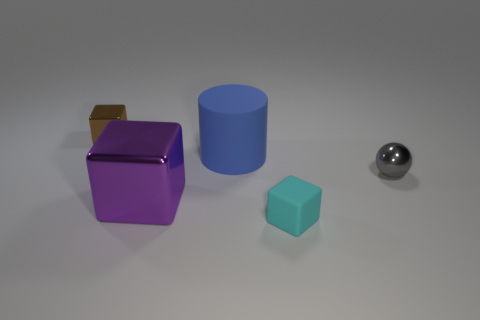There is a purple thing that is the same shape as the brown metallic object; what is its size?
Offer a very short reply. Large. Are there more blue rubber cylinders to the left of the small gray metal sphere than gray metallic things that are in front of the blue thing?
Your answer should be compact. No. What is the small object that is behind the matte cube and right of the large purple object made of?
Keep it short and to the point. Metal. There is another small metallic object that is the same shape as the small cyan thing; what color is it?
Make the answer very short. Brown. How big is the cylinder?
Your response must be concise. Large. There is a small block to the right of the tiny cube that is left of the small rubber thing; what color is it?
Ensure brevity in your answer.  Cyan. How many blocks are both on the left side of the big blue cylinder and in front of the tiny gray sphere?
Ensure brevity in your answer.  1. Are there more tiny cyan things than large red shiny balls?
Ensure brevity in your answer.  Yes. What is the big blue thing made of?
Provide a succinct answer. Rubber. There is a rubber object behind the tiny gray object; what number of blocks are in front of it?
Your response must be concise. 2. 